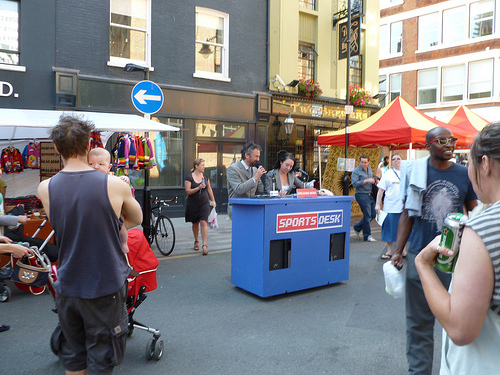<image>
Can you confirm if the tent is in front of the podium? No. The tent is not in front of the podium. The spatial positioning shows a different relationship between these objects. 